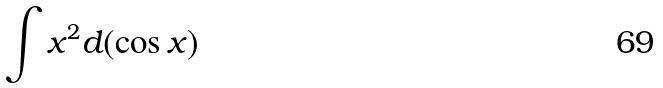<formula> <loc_0><loc_0><loc_500><loc_500>\int x ^ { 2 } d ( \cos x )</formula> 